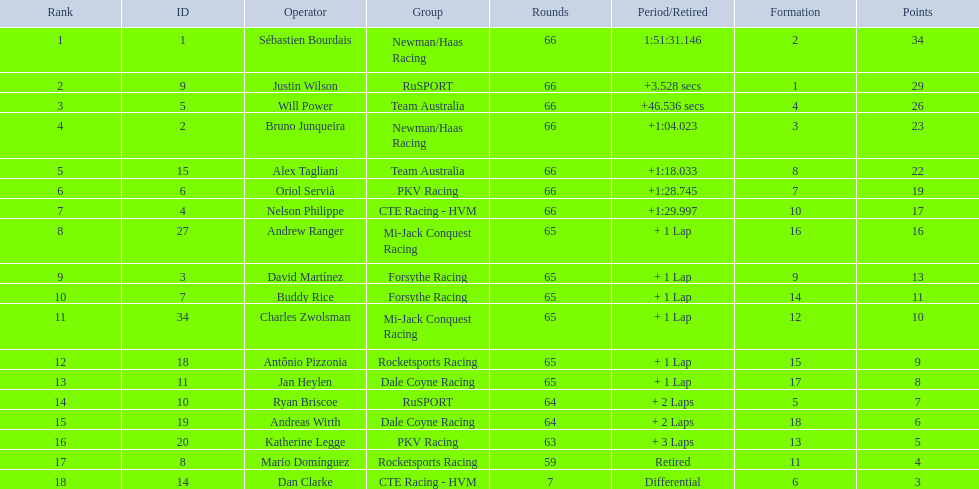What was the highest amount of points scored in the 2006 gran premio? 34. Who scored 34 points? Sébastien Bourdais. 